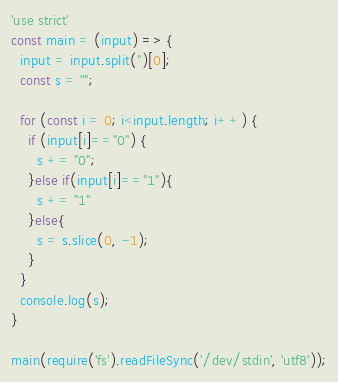Convert code to text. <code><loc_0><loc_0><loc_500><loc_500><_TypeScript_>'use strict'
const main = (input) => {
  input = input.split('')[0];
  const s = "";
  
  for (const i = 0; i<input.length; i++) {
    if (input[i]=="0") {
      s += "0";
    }else if(input[i]=="1"){
      s += "1"
    }else{
      s = s.slice(0, -1);
    }
  }
  console.log(s);
}
 
main(require('fs').readFileSync('/dev/stdin', 'utf8'));</code> 